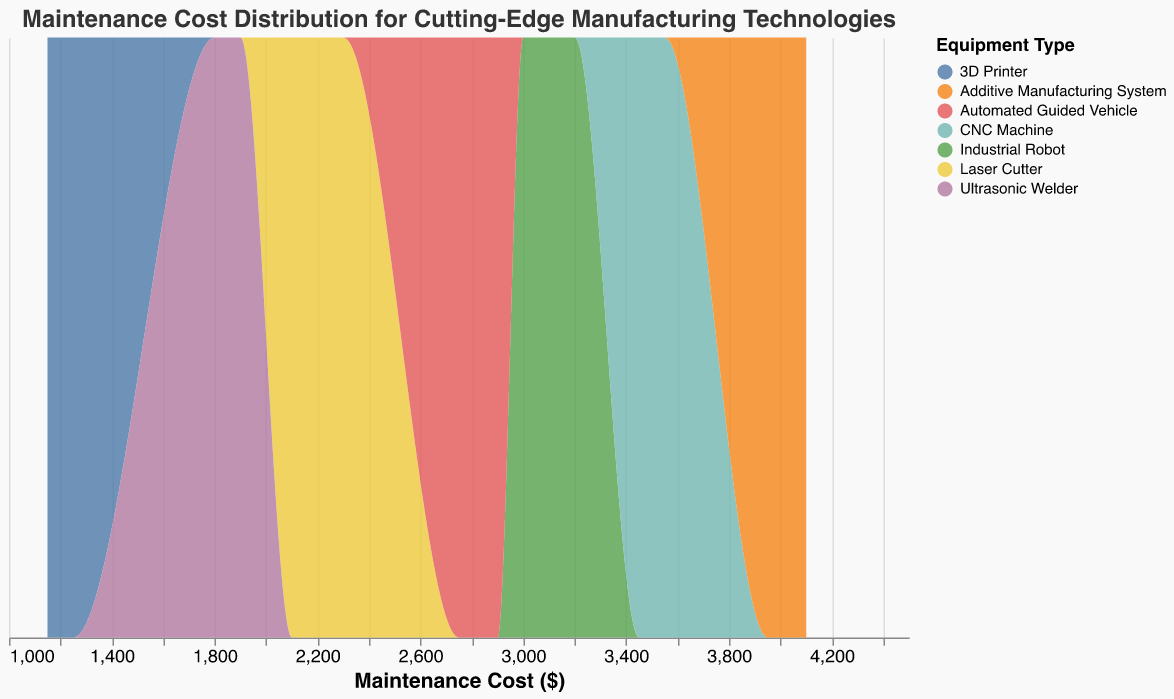What is the title of the plot? The title is displayed at the top of the plot. It reads "Maintenance Cost Distribution for Cutting-Edge Manufacturing Technologies".
Answer: Maintenance Cost Distribution for Cutting-Edge Manufacturing Technologies What does the x-axis in the plot represent? The x-axis label indicates it represents the "Maintenance Cost" in dollars.
Answer: Maintenance Cost ($) What are the different types of equipment included in the plot? The plot legend lists all the included equipment types: 3D Printer, Industrial Robot, Laser Cutter, CNC Machine, Automated Guided Vehicle, Ultrasonic Welder, Additive Manufacturing System.
Answer: 3D Printer, Industrial Robot, Laser Cutter, CNC Machine, Automated Guided Vehicle, Ultrasonic Welder, Additive Manufacturing System Which equipment type has the highest maintenance cost distribution peak? From the density peaks, the Additive Manufacturing System shows the highest maintenance cost distribution around the $4000 mark.
Answer: Additive Manufacturing System What is the range of maintenance costs for the 3D Printer? The data points for 3D Printer range between $1150 and $1250 on the x-axis.
Answer: $1150 - $1250 How does the maintenance cost distribution for CNC Machine compare to that of Automated Guided Vehicle? The CNC Machine has a higher cost range ($3450 - $3550) compared to the Automated Guided Vehicle ($2750 - $2900), indicating a higher maintenance cost overall.
Answer: CNC Machine has higher costs What is the approximate maintenance cost for Laser Cutter where it has the most density? The Laser Cutter's highest density for maintenance costs is around the $2200 mark.
Answer: $2200 Which equipment has the smallest spread in maintenance costs, and what is the range? Ultrasonic Welder has the smallest spread, with costs ranging from $1800 to $1900.
Answer: Ultrasonic Welder, $1800 - $1900 Which equipment shows the most variability in maintenance costs? The Industrial Robot shows the most variability in maintenance costs, with a range between $3000 and $3200.
Answer: Industrial Robot How does the peak maintenance cost of the Industrial Robot compare to that of the 3D Printer? The Industrial Robot peaks around $3100, which is much higher than the peak of the 3D Printer around $1200.
Answer: Higher 